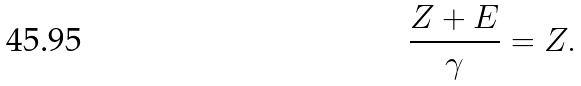<formula> <loc_0><loc_0><loc_500><loc_500>\frac { Z + E } { \gamma } = Z .</formula> 